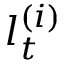<formula> <loc_0><loc_0><loc_500><loc_500>l _ { t } ^ { ( i ) }</formula> 